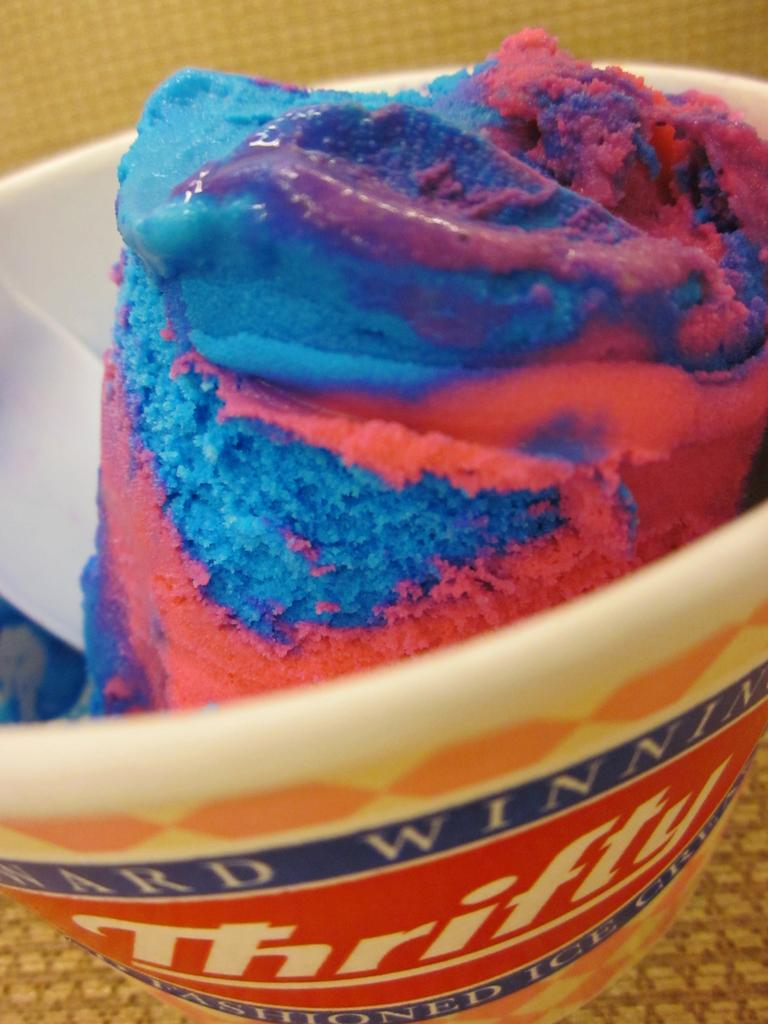What is the main subject of the image? The main subject of the image is a cup of ice cream. Where is the cup of ice cream located in the image? The cup of ice cream is in the center of the image. Can you tell me how many people are swimming in the image? There are no people swimming in the image, as it only features a cup of ice cream. What type of curve can be seen in the image? There is no curve present in the image; it only features a cup of ice cream. 